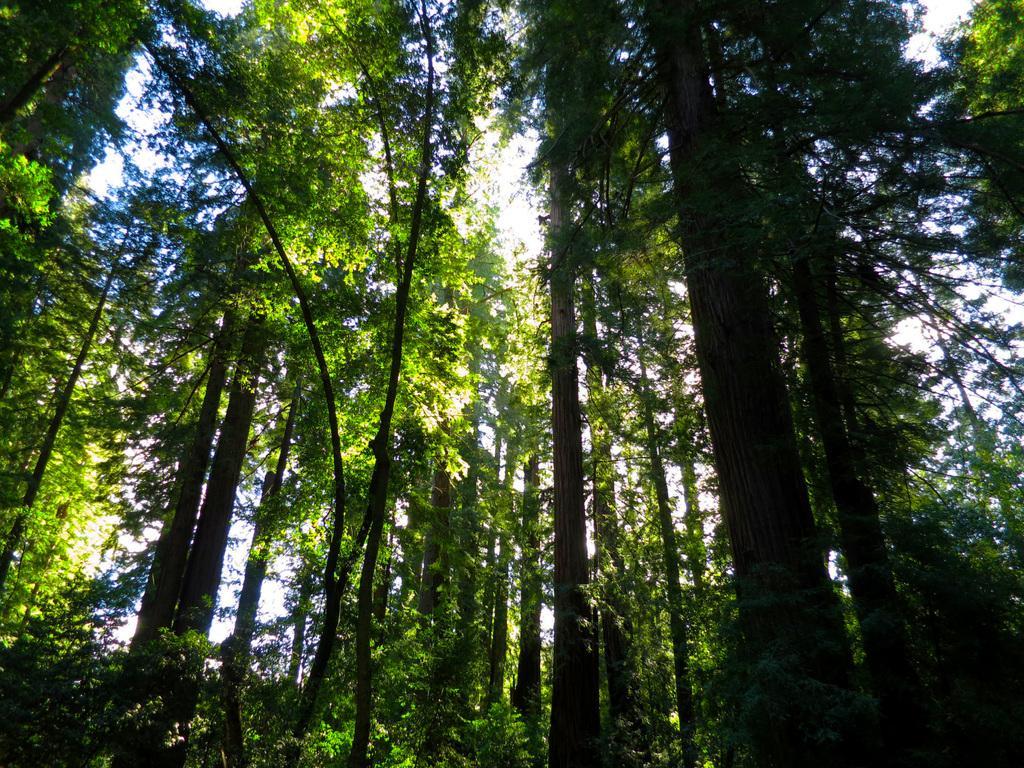How would you summarize this image in a sentence or two? In this image I can see trees in green color and the sky is in white color. 